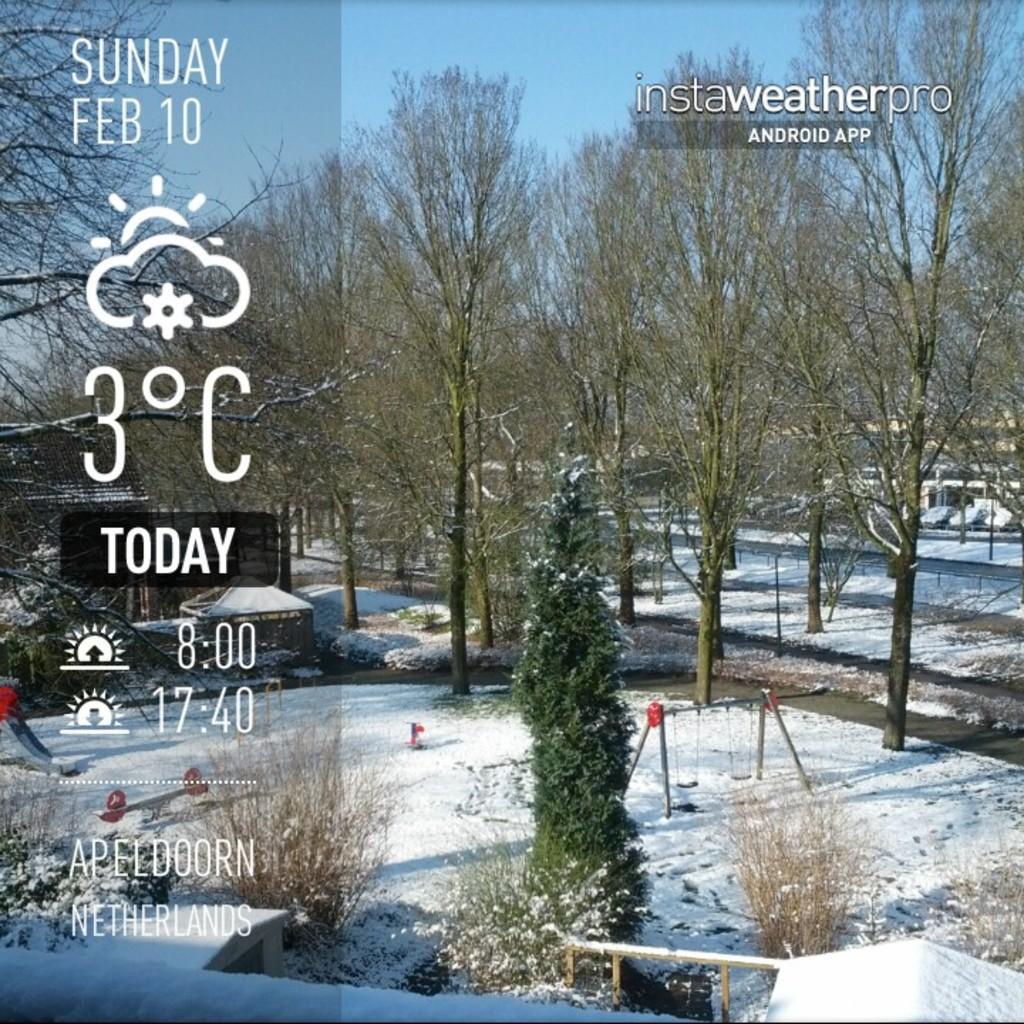Please provide a concise description of this image. In this image, we can see trees, some plants and there are some poles. At the bottom, there is snow and on the left, we can see some text written. 